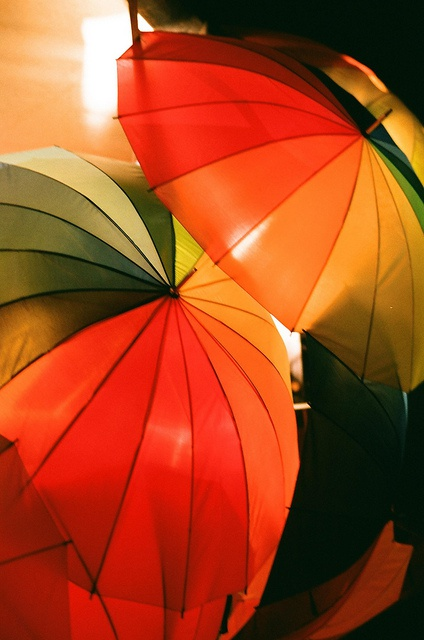Describe the objects in this image and their specific colors. I can see umbrella in orange, red, brown, and olive tones, umbrella in orange, red, and olive tones, umbrella in orange, black, maroon, brown, and red tones, and umbrella in maroon, black, and orange tones in this image. 